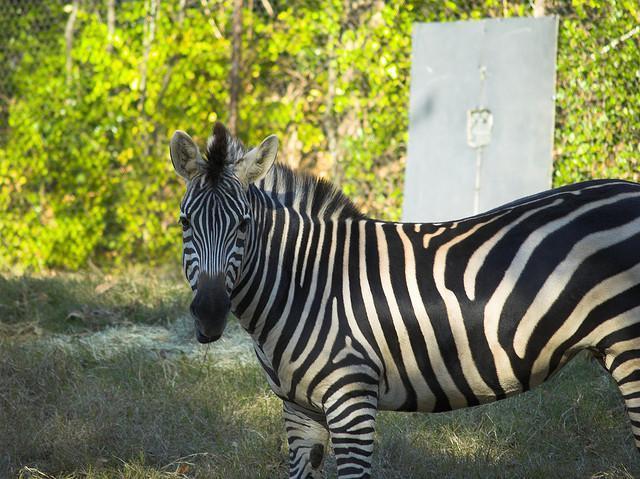How many legs of the zebra can you see?
Give a very brief answer. 3. How many animals are in the image?
Give a very brief answer. 1. How many zoo animals are there?
Give a very brief answer. 1. 